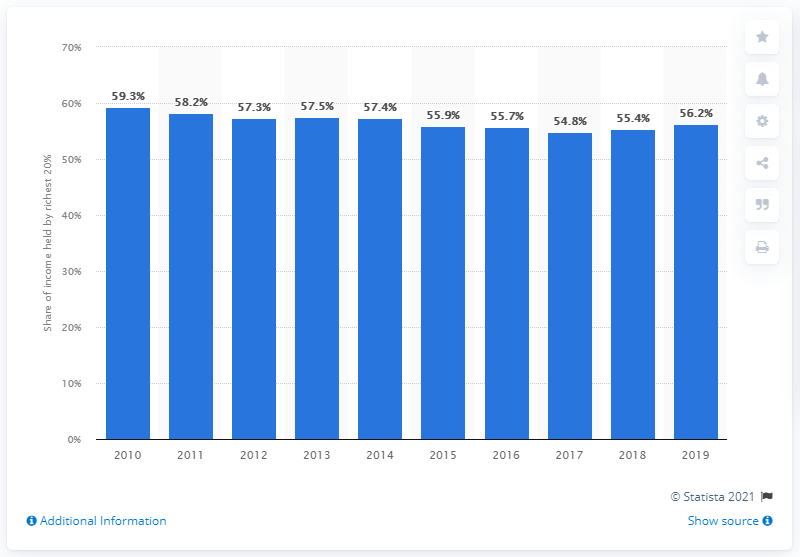Draw attention to some important aspects in this diagram. In 2017, the richest 20 percent of Colombia's population held 54.8 percent of the country's income. In 2019, the richest 20% of Colombia's population held 56.2% of the country's total income. 